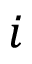<formula> <loc_0><loc_0><loc_500><loc_500>i</formula> 